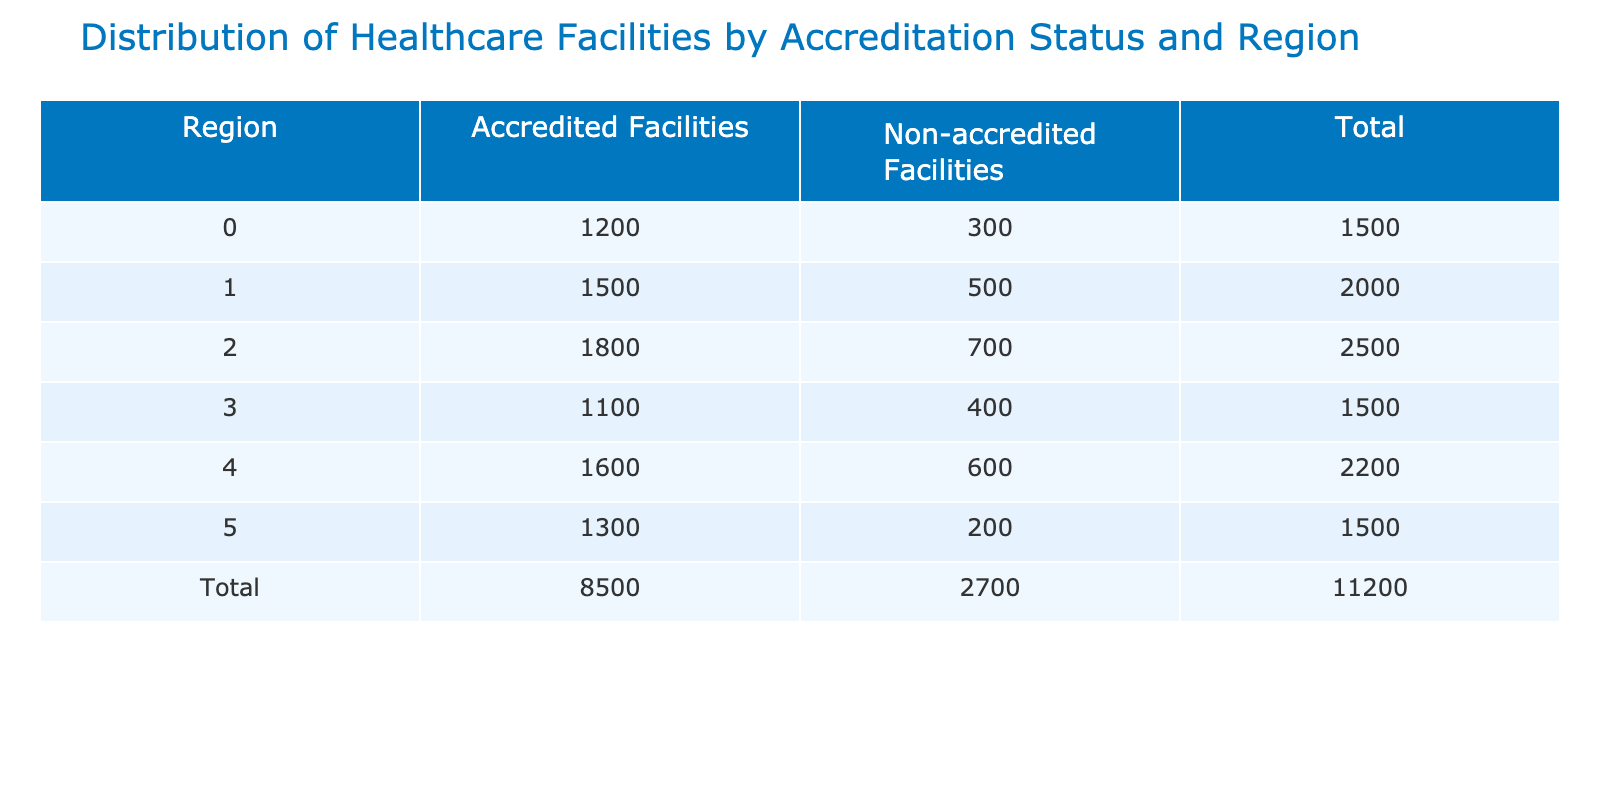What is the total number of accredited facilities in the Midwest? The accredited facilities in the Midwest are listed as 1500 in the table. Therefore, the total for the Midwest is directly taken from the corresponding column.
Answer: 1500 Which region has the highest number of non-accredited facilities? The non-accredited facilities for each region are: Northeast (300), Midwest (500), South (700), West (400), Southeast (600), and Pacific (200). By comparing these values, the South has the highest with 700 non-accredited facilities.
Answer: South What is the total number of healthcare facilities (both accredited and non-accredited) in the Northeast? The Northeast has 1200 accredited and 300 non-accredited facilities. Summing these gives 1200 + 300 = 1500 as the total for the Northeast region.
Answer: 1500 How many more accredited facilities are in the South compared to the West? The South has 1800 accredited facilities, while the West has 1100. To find the difference, subtract the number of accredited facilities in the West from those in the South: 1800 - 1100 = 700.
Answer: 700 Is the total number of accredited facilities across all regions greater than the total number of non-accredited facilities? First, we calculate the total accredited facilities: 1200 + 1500 + 1800 + 1100 + 1600 + 1300 = 10300. Then, the total non-accredited facilities: 300 + 500 + 700 + 400 + 600 + 200 = 2700. Since 10300 is greater than 2700, the answer is yes.
Answer: Yes What is the average number of accredited facilities across all regions? To calculate the average, we first sum the accredited facilities: 1200 + 1500 + 1800 + 1100 + 1600 + 1300 = 10300. There are 6 regions, so we divide by 6: 10300 / 6 ≈ 1716.67.
Answer: 1716.67 Which region has the lowest total number of healthcare facilities? The total number of facilities for each region: Northeast (1500), Midwest (2000), South (2500), West (1500), Southeast (2200), and Pacific (1500). The Northeast, West, and Pacific all have the lowest total of 1500.
Answer: Northeast, West, and Pacific What is the median number of non-accredited facilities among all regions? The number of non-accredited facilities are: 300, 500, 700, 400, 600, and 200. When sorted (200, 300, 400, 500, 600, 700), the median is the average of the 3rd and 4th values: (400 + 500) / 2 = 450.
Answer: 450 